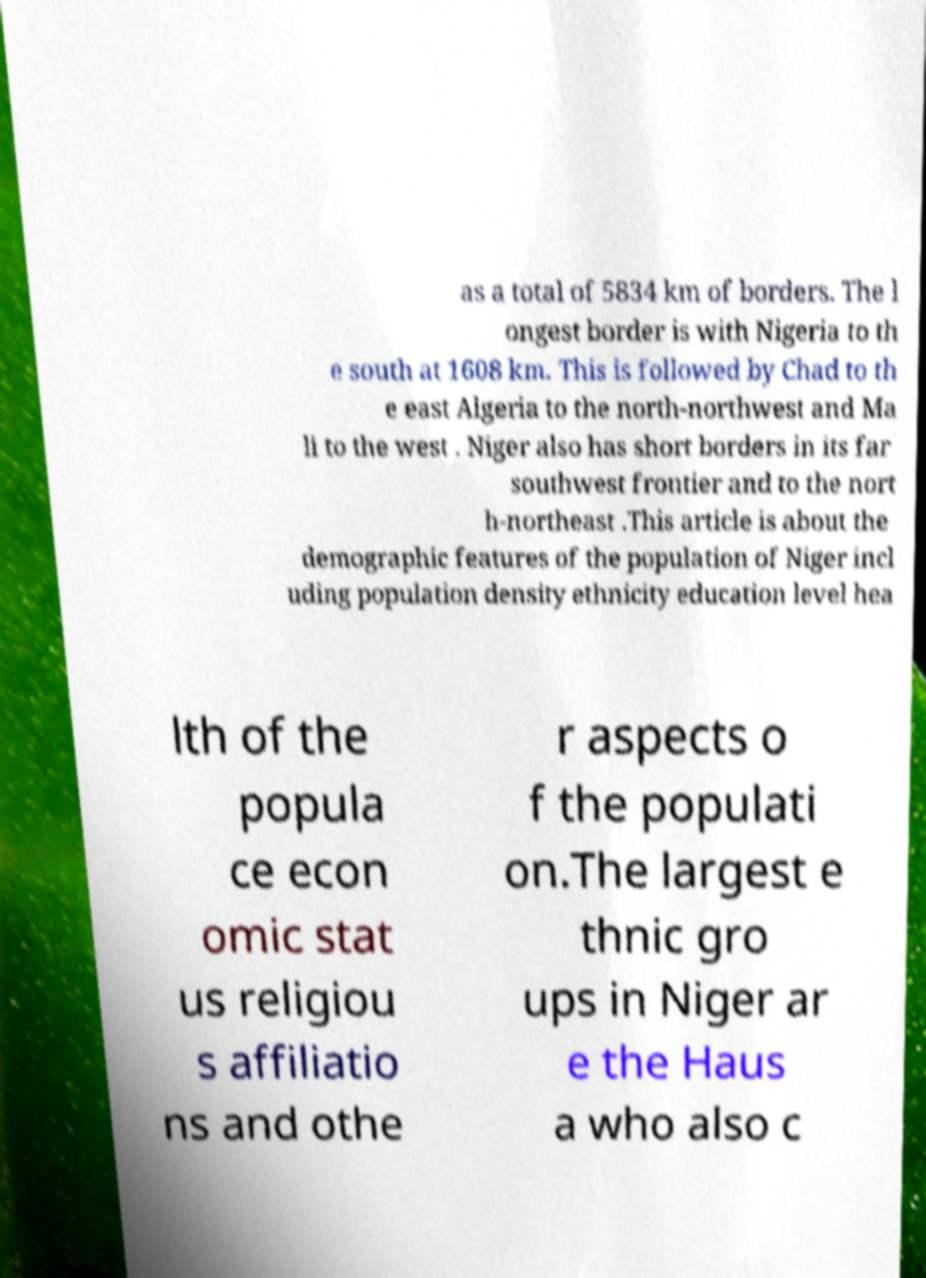What messages or text are displayed in this image? I need them in a readable, typed format. as a total of 5834 km of borders. The l ongest border is with Nigeria to th e south at 1608 km. This is followed by Chad to th e east Algeria to the north-northwest and Ma li to the west . Niger also has short borders in its far southwest frontier and to the nort h-northeast .This article is about the demographic features of the population of Niger incl uding population density ethnicity education level hea lth of the popula ce econ omic stat us religiou s affiliatio ns and othe r aspects o f the populati on.The largest e thnic gro ups in Niger ar e the Haus a who also c 